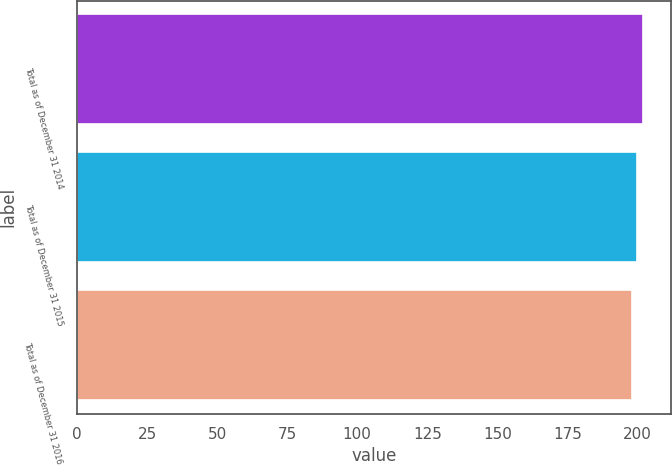Convert chart to OTSL. <chart><loc_0><loc_0><loc_500><loc_500><bar_chart><fcel>Total as of December 31 2014<fcel>Total as of December 31 2015<fcel>Total as of December 31 2016<nl><fcel>202<fcel>200<fcel>198<nl></chart> 